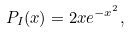<formula> <loc_0><loc_0><loc_500><loc_500>P _ { I } ( x ) = 2 x e ^ { - x ^ { 2 } } ,</formula> 